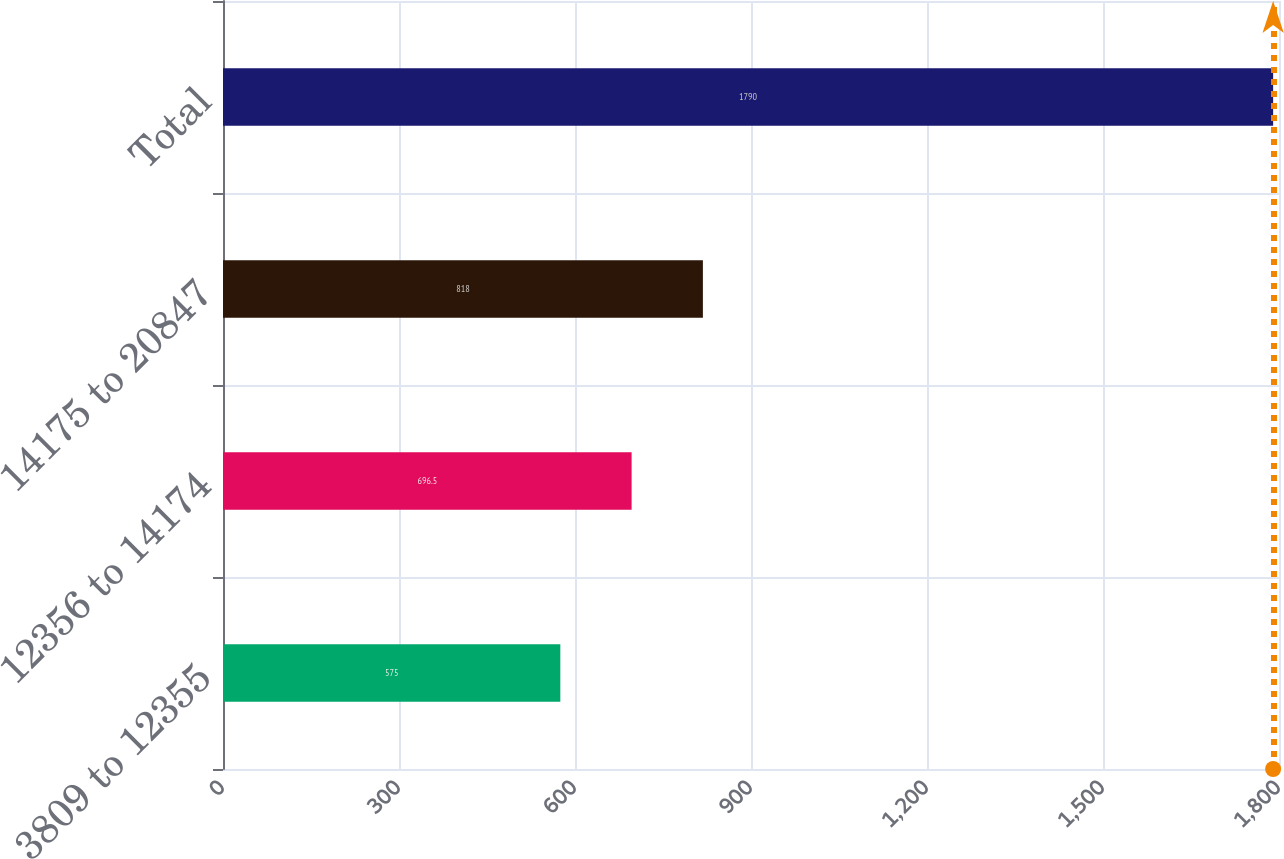Convert chart. <chart><loc_0><loc_0><loc_500><loc_500><bar_chart><fcel>3809 to 12355<fcel>12356 to 14174<fcel>14175 to 20847<fcel>Total<nl><fcel>575<fcel>696.5<fcel>818<fcel>1790<nl></chart> 